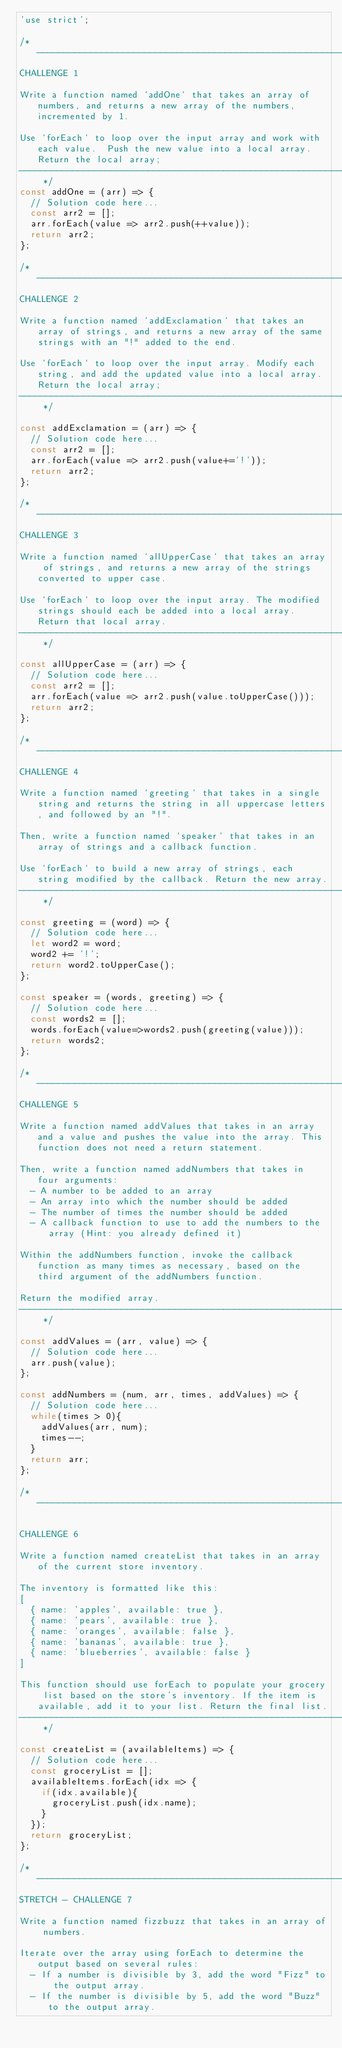<code> <loc_0><loc_0><loc_500><loc_500><_JavaScript_>'use strict';

/* ------------------------------------------------------------------------------------------------
CHALLENGE 1

Write a function named `addOne` that takes an array of numbers, and returns a new array of the numbers, incremented by 1.

Use `forEach` to loop over the input array and work with each value.  Push the new value into a local array. Return the local array;
------------------------------------------------------------------------------------------------ */
const addOne = (arr) => {
  // Solution code here...
  const arr2 = [];
  arr.forEach(value => arr2.push(++value));
  return arr2;
};

/* ------------------------------------------------------------------------------------------------
CHALLENGE 2

Write a function named `addExclamation` that takes an array of strings, and returns a new array of the same strings with an "!" added to the end.

Use `forEach` to loop over the input array. Modify each string, and add the updated value into a local array. Return the local array;
------------------------------------------------------------------------------------------------ */

const addExclamation = (arr) => {
  // Solution code here...
  const arr2 = [];
  arr.forEach(value => arr2.push(value+='!'));
  return arr2;
};

/* ------------------------------------------------------------------------------------------------
CHALLENGE 3

Write a function named `allUpperCase` that takes an array of strings, and returns a new array of the strings converted to upper case.

Use `forEach` to loop over the input array. The modified strings should each be added into a local array. Return that local array.
------------------------------------------------------------------------------------------------ */

const allUpperCase = (arr) => {
  // Solution code here...
  const arr2 = [];
  arr.forEach(value => arr2.push(value.toUpperCase()));
  return arr2;
};

/* ------------------------------------------------------------------------------------------------
CHALLENGE 4

Write a function named `greeting` that takes in a single string and returns the string in all uppercase letters, and followed by an "!".

Then, write a function named `speaker` that takes in an array of strings and a callback function. 

Use `forEach` to build a new array of strings, each string modified by the callback. Return the new array. 
------------------------------------------------------------------------------------------------ */

const greeting = (word) => {
  // Solution code here...
  let word2 = word;
  word2 += '!';
  return word2.toUpperCase();
};

const speaker = (words, greeting) => {
  // Solution code here...
  const words2 = [];
  words.forEach(value=>words2.push(greeting(value)));
  return words2;
};

/* ------------------------------------------------------------------------------------------------
CHALLENGE 5

Write a function named addValues that takes in an array and a value and pushes the value into the array. This function does not need a return statement.

Then, write a function named addNumbers that takes in four arguments:
  - A number to be added to an array
  - An array into which the number should be added
  - The number of times the number should be added
  - A callback function to use to add the numbers to the array (Hint: you already defined it)

Within the addNumbers function, invoke the callback function as many times as necessary, based on the third argument of the addNumbers function.

Return the modified array.
------------------------------------------------------------------------------------------------ */

const addValues = (arr, value) => {
  // Solution code here...
  arr.push(value);
};

const addNumbers = (num, arr, times, addValues) => {
  // Solution code here...
  while(times > 0){
    addValues(arr, num);
    times--;
  }
  return arr;
};

/* ------------------------------------------------------------------------------------------------

CHALLENGE 6

Write a function named createList that takes in an array of the current store inventory.

The inventory is formatted like this:
[
  { name: 'apples', available: true },
  { name: 'pears', available: true },
  { name: 'oranges', available: false },
  { name: 'bananas', available: true },
  { name: 'blueberries', available: false }
]

This function should use forEach to populate your grocery list based on the store's inventory. If the item is available, add it to your list. Return the final list.
------------------------------------------------------------------------------------------------ */

const createList = (availableItems) => {
  // Solution code here...
  const groceryList = [];
  availableItems.forEach(idx => {
    if(idx.available){
      groceryList.push(idx.name);
    }
  });
  return groceryList;
};

/* ------------------------------------------------------------------------------------------------
STRETCH - CHALLENGE 7

Write a function named fizzbuzz that takes in an array of numbers.

Iterate over the array using forEach to determine the output based on several rules:
  - If a number is divisible by 3, add the word "Fizz" to the output array.
  - If the number is divisible by 5, add the word "Buzz" to the output array.</code> 